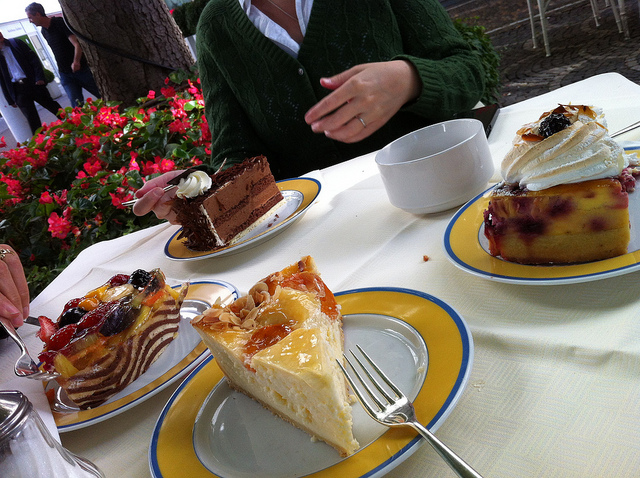Imagine I'm planning a similar gathering, how would you suggest I set the table? To recreate this charming setup for your gathering, start with a simple, elegant tablecloth to create a clean and inviting backdrop for your desserts. Arrange your plates in an accessible pattern, each accompanied by the appropriate cutlery, ensuring that guests can easily serve themselves. Place each cake artfully on the plates, allowing for a variety of colors and textures to draw the eye. Consider adding some fresh flowers or potted plants nearby, which will not only enhance the natural beauty of your setting but also complement the sweetness of the cakes with a fresh, fragrant aroma. 